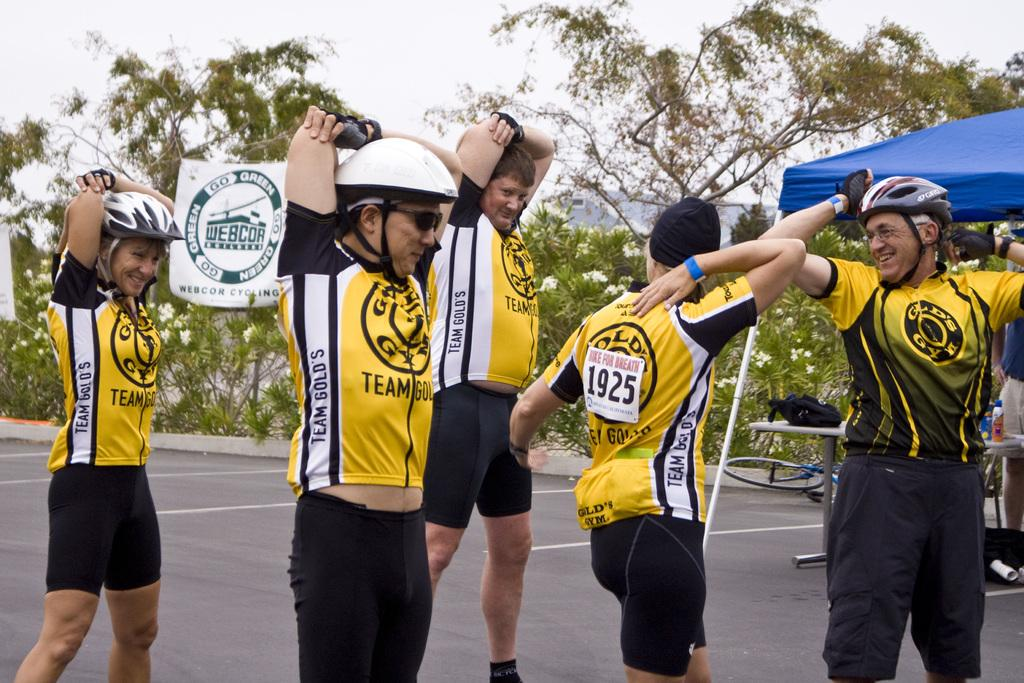Provide a one-sentence caption for the provided image. The bikers of Team Gold's are stretching before the bike race. 